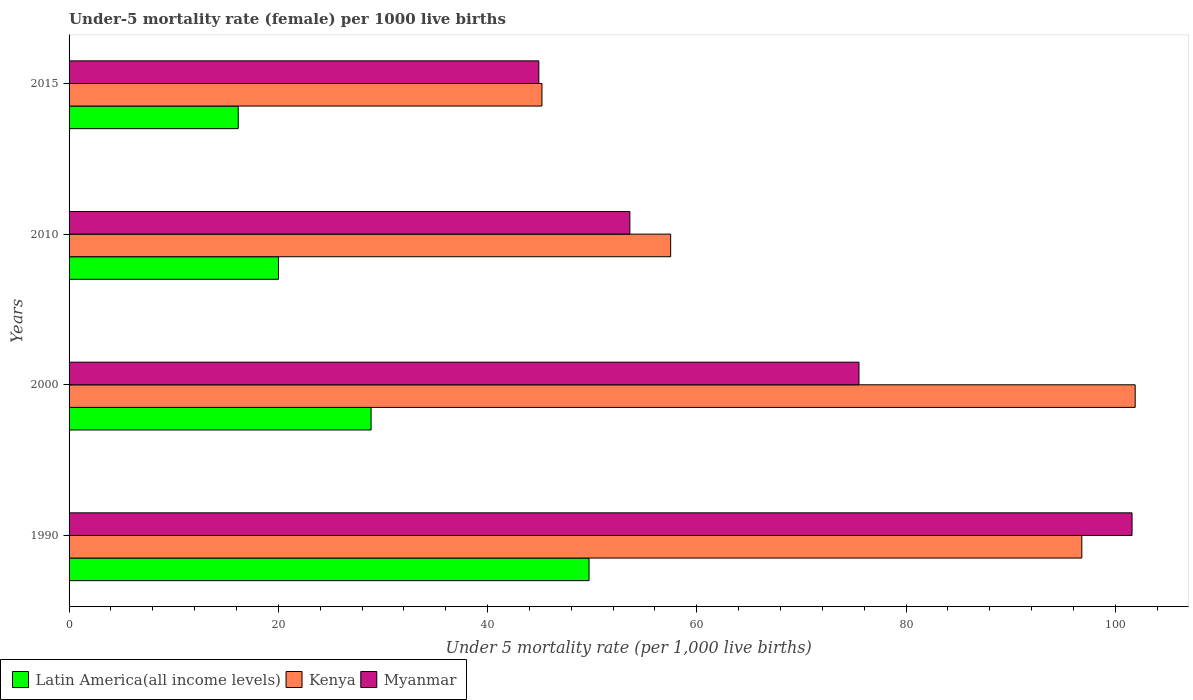How many different coloured bars are there?
Make the answer very short. 3. How many groups of bars are there?
Provide a short and direct response. 4. What is the under-five mortality rate in Kenya in 2015?
Your response must be concise. 45.2. Across all years, what is the maximum under-five mortality rate in Kenya?
Your answer should be very brief. 101.9. Across all years, what is the minimum under-five mortality rate in Latin America(all income levels)?
Offer a very short reply. 16.17. In which year was the under-five mortality rate in Latin America(all income levels) minimum?
Your response must be concise. 2015. What is the total under-five mortality rate in Kenya in the graph?
Offer a terse response. 301.4. What is the difference between the under-five mortality rate in Kenya in 2000 and that in 2015?
Your response must be concise. 56.7. What is the difference between the under-five mortality rate in Kenya in 1990 and the under-five mortality rate in Myanmar in 2015?
Offer a terse response. 51.9. What is the average under-five mortality rate in Kenya per year?
Offer a very short reply. 75.35. In the year 2015, what is the difference between the under-five mortality rate in Latin America(all income levels) and under-five mortality rate in Myanmar?
Ensure brevity in your answer.  -28.73. In how many years, is the under-five mortality rate in Latin America(all income levels) greater than 76 ?
Offer a terse response. 0. What is the ratio of the under-five mortality rate in Myanmar in 2000 to that in 2015?
Keep it short and to the point. 1.68. Is the under-five mortality rate in Myanmar in 2000 less than that in 2010?
Your response must be concise. No. Is the difference between the under-five mortality rate in Latin America(all income levels) in 1990 and 2000 greater than the difference between the under-five mortality rate in Myanmar in 1990 and 2000?
Keep it short and to the point. No. What is the difference between the highest and the second highest under-five mortality rate in Latin America(all income levels)?
Give a very brief answer. 20.83. What is the difference between the highest and the lowest under-five mortality rate in Latin America(all income levels)?
Your response must be concise. 33.53. What does the 2nd bar from the top in 1990 represents?
Offer a terse response. Kenya. What does the 3rd bar from the bottom in 2000 represents?
Your answer should be very brief. Myanmar. Is it the case that in every year, the sum of the under-five mortality rate in Myanmar and under-five mortality rate in Kenya is greater than the under-five mortality rate in Latin America(all income levels)?
Make the answer very short. Yes. What is the difference between two consecutive major ticks on the X-axis?
Give a very brief answer. 20. Are the values on the major ticks of X-axis written in scientific E-notation?
Keep it short and to the point. No. Does the graph contain any zero values?
Provide a short and direct response. No. Does the graph contain grids?
Your answer should be very brief. No. Where does the legend appear in the graph?
Make the answer very short. Bottom left. What is the title of the graph?
Keep it short and to the point. Under-5 mortality rate (female) per 1000 live births. Does "Costa Rica" appear as one of the legend labels in the graph?
Provide a succinct answer. No. What is the label or title of the X-axis?
Offer a very short reply. Under 5 mortality rate (per 1,0 live births). What is the Under 5 mortality rate (per 1,000 live births) in Latin America(all income levels) in 1990?
Provide a short and direct response. 49.7. What is the Under 5 mortality rate (per 1,000 live births) in Kenya in 1990?
Your response must be concise. 96.8. What is the Under 5 mortality rate (per 1,000 live births) in Myanmar in 1990?
Offer a very short reply. 101.6. What is the Under 5 mortality rate (per 1,000 live births) in Latin America(all income levels) in 2000?
Offer a terse response. 28.87. What is the Under 5 mortality rate (per 1,000 live births) in Kenya in 2000?
Provide a short and direct response. 101.9. What is the Under 5 mortality rate (per 1,000 live births) in Myanmar in 2000?
Provide a short and direct response. 75.5. What is the Under 5 mortality rate (per 1,000 live births) in Latin America(all income levels) in 2010?
Provide a short and direct response. 20.02. What is the Under 5 mortality rate (per 1,000 live births) of Kenya in 2010?
Offer a very short reply. 57.5. What is the Under 5 mortality rate (per 1,000 live births) of Myanmar in 2010?
Provide a short and direct response. 53.6. What is the Under 5 mortality rate (per 1,000 live births) in Latin America(all income levels) in 2015?
Provide a succinct answer. 16.17. What is the Under 5 mortality rate (per 1,000 live births) in Kenya in 2015?
Keep it short and to the point. 45.2. What is the Under 5 mortality rate (per 1,000 live births) of Myanmar in 2015?
Your answer should be compact. 44.9. Across all years, what is the maximum Under 5 mortality rate (per 1,000 live births) of Latin America(all income levels)?
Ensure brevity in your answer.  49.7. Across all years, what is the maximum Under 5 mortality rate (per 1,000 live births) of Kenya?
Your response must be concise. 101.9. Across all years, what is the maximum Under 5 mortality rate (per 1,000 live births) of Myanmar?
Give a very brief answer. 101.6. Across all years, what is the minimum Under 5 mortality rate (per 1,000 live births) of Latin America(all income levels)?
Give a very brief answer. 16.17. Across all years, what is the minimum Under 5 mortality rate (per 1,000 live births) in Kenya?
Ensure brevity in your answer.  45.2. Across all years, what is the minimum Under 5 mortality rate (per 1,000 live births) of Myanmar?
Offer a terse response. 44.9. What is the total Under 5 mortality rate (per 1,000 live births) in Latin America(all income levels) in the graph?
Provide a succinct answer. 114.75. What is the total Under 5 mortality rate (per 1,000 live births) in Kenya in the graph?
Give a very brief answer. 301.4. What is the total Under 5 mortality rate (per 1,000 live births) of Myanmar in the graph?
Offer a terse response. 275.6. What is the difference between the Under 5 mortality rate (per 1,000 live births) in Latin America(all income levels) in 1990 and that in 2000?
Offer a terse response. 20.83. What is the difference between the Under 5 mortality rate (per 1,000 live births) in Kenya in 1990 and that in 2000?
Provide a succinct answer. -5.1. What is the difference between the Under 5 mortality rate (per 1,000 live births) in Myanmar in 1990 and that in 2000?
Provide a short and direct response. 26.1. What is the difference between the Under 5 mortality rate (per 1,000 live births) in Latin America(all income levels) in 1990 and that in 2010?
Your answer should be compact. 29.68. What is the difference between the Under 5 mortality rate (per 1,000 live births) of Kenya in 1990 and that in 2010?
Provide a short and direct response. 39.3. What is the difference between the Under 5 mortality rate (per 1,000 live births) of Latin America(all income levels) in 1990 and that in 2015?
Offer a terse response. 33.53. What is the difference between the Under 5 mortality rate (per 1,000 live births) of Kenya in 1990 and that in 2015?
Your response must be concise. 51.6. What is the difference between the Under 5 mortality rate (per 1,000 live births) of Myanmar in 1990 and that in 2015?
Your answer should be very brief. 56.7. What is the difference between the Under 5 mortality rate (per 1,000 live births) of Latin America(all income levels) in 2000 and that in 2010?
Make the answer very short. 8.85. What is the difference between the Under 5 mortality rate (per 1,000 live births) in Kenya in 2000 and that in 2010?
Provide a succinct answer. 44.4. What is the difference between the Under 5 mortality rate (per 1,000 live births) in Myanmar in 2000 and that in 2010?
Provide a succinct answer. 21.9. What is the difference between the Under 5 mortality rate (per 1,000 live births) of Latin America(all income levels) in 2000 and that in 2015?
Provide a short and direct response. 12.7. What is the difference between the Under 5 mortality rate (per 1,000 live births) in Kenya in 2000 and that in 2015?
Ensure brevity in your answer.  56.7. What is the difference between the Under 5 mortality rate (per 1,000 live births) in Myanmar in 2000 and that in 2015?
Ensure brevity in your answer.  30.6. What is the difference between the Under 5 mortality rate (per 1,000 live births) of Latin America(all income levels) in 2010 and that in 2015?
Give a very brief answer. 3.85. What is the difference between the Under 5 mortality rate (per 1,000 live births) in Latin America(all income levels) in 1990 and the Under 5 mortality rate (per 1,000 live births) in Kenya in 2000?
Offer a very short reply. -52.2. What is the difference between the Under 5 mortality rate (per 1,000 live births) in Latin America(all income levels) in 1990 and the Under 5 mortality rate (per 1,000 live births) in Myanmar in 2000?
Offer a terse response. -25.8. What is the difference between the Under 5 mortality rate (per 1,000 live births) in Kenya in 1990 and the Under 5 mortality rate (per 1,000 live births) in Myanmar in 2000?
Your answer should be very brief. 21.3. What is the difference between the Under 5 mortality rate (per 1,000 live births) in Latin America(all income levels) in 1990 and the Under 5 mortality rate (per 1,000 live births) in Kenya in 2010?
Give a very brief answer. -7.8. What is the difference between the Under 5 mortality rate (per 1,000 live births) in Latin America(all income levels) in 1990 and the Under 5 mortality rate (per 1,000 live births) in Myanmar in 2010?
Your answer should be compact. -3.9. What is the difference between the Under 5 mortality rate (per 1,000 live births) of Kenya in 1990 and the Under 5 mortality rate (per 1,000 live births) of Myanmar in 2010?
Provide a short and direct response. 43.2. What is the difference between the Under 5 mortality rate (per 1,000 live births) in Latin America(all income levels) in 1990 and the Under 5 mortality rate (per 1,000 live births) in Kenya in 2015?
Your answer should be very brief. 4.5. What is the difference between the Under 5 mortality rate (per 1,000 live births) of Latin America(all income levels) in 1990 and the Under 5 mortality rate (per 1,000 live births) of Myanmar in 2015?
Provide a succinct answer. 4.8. What is the difference between the Under 5 mortality rate (per 1,000 live births) in Kenya in 1990 and the Under 5 mortality rate (per 1,000 live births) in Myanmar in 2015?
Your answer should be compact. 51.9. What is the difference between the Under 5 mortality rate (per 1,000 live births) of Latin America(all income levels) in 2000 and the Under 5 mortality rate (per 1,000 live births) of Kenya in 2010?
Give a very brief answer. -28.63. What is the difference between the Under 5 mortality rate (per 1,000 live births) of Latin America(all income levels) in 2000 and the Under 5 mortality rate (per 1,000 live births) of Myanmar in 2010?
Offer a very short reply. -24.73. What is the difference between the Under 5 mortality rate (per 1,000 live births) in Kenya in 2000 and the Under 5 mortality rate (per 1,000 live births) in Myanmar in 2010?
Your answer should be compact. 48.3. What is the difference between the Under 5 mortality rate (per 1,000 live births) in Latin America(all income levels) in 2000 and the Under 5 mortality rate (per 1,000 live births) in Kenya in 2015?
Ensure brevity in your answer.  -16.33. What is the difference between the Under 5 mortality rate (per 1,000 live births) of Latin America(all income levels) in 2000 and the Under 5 mortality rate (per 1,000 live births) of Myanmar in 2015?
Provide a succinct answer. -16.03. What is the difference between the Under 5 mortality rate (per 1,000 live births) of Latin America(all income levels) in 2010 and the Under 5 mortality rate (per 1,000 live births) of Kenya in 2015?
Make the answer very short. -25.18. What is the difference between the Under 5 mortality rate (per 1,000 live births) of Latin America(all income levels) in 2010 and the Under 5 mortality rate (per 1,000 live births) of Myanmar in 2015?
Your response must be concise. -24.88. What is the average Under 5 mortality rate (per 1,000 live births) in Latin America(all income levels) per year?
Your answer should be compact. 28.69. What is the average Under 5 mortality rate (per 1,000 live births) in Kenya per year?
Offer a terse response. 75.35. What is the average Under 5 mortality rate (per 1,000 live births) of Myanmar per year?
Make the answer very short. 68.9. In the year 1990, what is the difference between the Under 5 mortality rate (per 1,000 live births) of Latin America(all income levels) and Under 5 mortality rate (per 1,000 live births) of Kenya?
Provide a short and direct response. -47.1. In the year 1990, what is the difference between the Under 5 mortality rate (per 1,000 live births) in Latin America(all income levels) and Under 5 mortality rate (per 1,000 live births) in Myanmar?
Provide a succinct answer. -51.9. In the year 1990, what is the difference between the Under 5 mortality rate (per 1,000 live births) of Kenya and Under 5 mortality rate (per 1,000 live births) of Myanmar?
Offer a very short reply. -4.8. In the year 2000, what is the difference between the Under 5 mortality rate (per 1,000 live births) of Latin America(all income levels) and Under 5 mortality rate (per 1,000 live births) of Kenya?
Provide a short and direct response. -73.03. In the year 2000, what is the difference between the Under 5 mortality rate (per 1,000 live births) in Latin America(all income levels) and Under 5 mortality rate (per 1,000 live births) in Myanmar?
Your answer should be very brief. -46.63. In the year 2000, what is the difference between the Under 5 mortality rate (per 1,000 live births) in Kenya and Under 5 mortality rate (per 1,000 live births) in Myanmar?
Keep it short and to the point. 26.4. In the year 2010, what is the difference between the Under 5 mortality rate (per 1,000 live births) of Latin America(all income levels) and Under 5 mortality rate (per 1,000 live births) of Kenya?
Make the answer very short. -37.48. In the year 2010, what is the difference between the Under 5 mortality rate (per 1,000 live births) in Latin America(all income levels) and Under 5 mortality rate (per 1,000 live births) in Myanmar?
Provide a short and direct response. -33.58. In the year 2015, what is the difference between the Under 5 mortality rate (per 1,000 live births) in Latin America(all income levels) and Under 5 mortality rate (per 1,000 live births) in Kenya?
Offer a very short reply. -29.03. In the year 2015, what is the difference between the Under 5 mortality rate (per 1,000 live births) in Latin America(all income levels) and Under 5 mortality rate (per 1,000 live births) in Myanmar?
Provide a short and direct response. -28.73. In the year 2015, what is the difference between the Under 5 mortality rate (per 1,000 live births) of Kenya and Under 5 mortality rate (per 1,000 live births) of Myanmar?
Offer a terse response. 0.3. What is the ratio of the Under 5 mortality rate (per 1,000 live births) in Latin America(all income levels) in 1990 to that in 2000?
Keep it short and to the point. 1.72. What is the ratio of the Under 5 mortality rate (per 1,000 live births) of Myanmar in 1990 to that in 2000?
Make the answer very short. 1.35. What is the ratio of the Under 5 mortality rate (per 1,000 live births) in Latin America(all income levels) in 1990 to that in 2010?
Make the answer very short. 2.48. What is the ratio of the Under 5 mortality rate (per 1,000 live births) in Kenya in 1990 to that in 2010?
Provide a succinct answer. 1.68. What is the ratio of the Under 5 mortality rate (per 1,000 live births) of Myanmar in 1990 to that in 2010?
Provide a succinct answer. 1.9. What is the ratio of the Under 5 mortality rate (per 1,000 live births) in Latin America(all income levels) in 1990 to that in 2015?
Ensure brevity in your answer.  3.07. What is the ratio of the Under 5 mortality rate (per 1,000 live births) in Kenya in 1990 to that in 2015?
Your answer should be very brief. 2.14. What is the ratio of the Under 5 mortality rate (per 1,000 live births) of Myanmar in 1990 to that in 2015?
Your answer should be compact. 2.26. What is the ratio of the Under 5 mortality rate (per 1,000 live births) in Latin America(all income levels) in 2000 to that in 2010?
Give a very brief answer. 1.44. What is the ratio of the Under 5 mortality rate (per 1,000 live births) of Kenya in 2000 to that in 2010?
Your response must be concise. 1.77. What is the ratio of the Under 5 mortality rate (per 1,000 live births) of Myanmar in 2000 to that in 2010?
Ensure brevity in your answer.  1.41. What is the ratio of the Under 5 mortality rate (per 1,000 live births) of Latin America(all income levels) in 2000 to that in 2015?
Your answer should be compact. 1.79. What is the ratio of the Under 5 mortality rate (per 1,000 live births) of Kenya in 2000 to that in 2015?
Offer a terse response. 2.25. What is the ratio of the Under 5 mortality rate (per 1,000 live births) of Myanmar in 2000 to that in 2015?
Provide a short and direct response. 1.68. What is the ratio of the Under 5 mortality rate (per 1,000 live births) in Latin America(all income levels) in 2010 to that in 2015?
Offer a terse response. 1.24. What is the ratio of the Under 5 mortality rate (per 1,000 live births) in Kenya in 2010 to that in 2015?
Give a very brief answer. 1.27. What is the ratio of the Under 5 mortality rate (per 1,000 live births) in Myanmar in 2010 to that in 2015?
Your response must be concise. 1.19. What is the difference between the highest and the second highest Under 5 mortality rate (per 1,000 live births) in Latin America(all income levels)?
Ensure brevity in your answer.  20.83. What is the difference between the highest and the second highest Under 5 mortality rate (per 1,000 live births) in Myanmar?
Keep it short and to the point. 26.1. What is the difference between the highest and the lowest Under 5 mortality rate (per 1,000 live births) of Latin America(all income levels)?
Keep it short and to the point. 33.53. What is the difference between the highest and the lowest Under 5 mortality rate (per 1,000 live births) in Kenya?
Ensure brevity in your answer.  56.7. What is the difference between the highest and the lowest Under 5 mortality rate (per 1,000 live births) of Myanmar?
Keep it short and to the point. 56.7. 